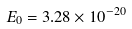Convert formula to latex. <formula><loc_0><loc_0><loc_500><loc_500>E _ { 0 } = 3 . 2 8 \times 1 0 ^ { - 2 0 }</formula> 